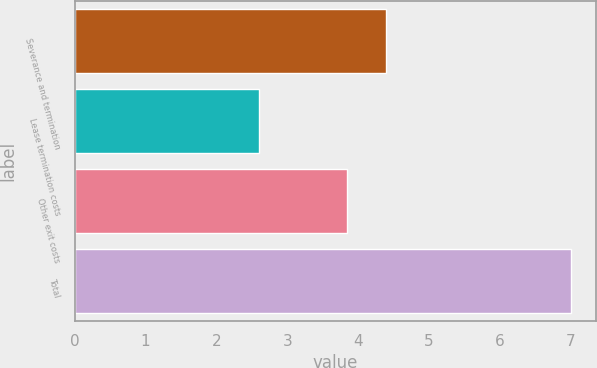Convert chart to OTSL. <chart><loc_0><loc_0><loc_500><loc_500><bar_chart><fcel>Severance and termination<fcel>Lease termination costs<fcel>Other exit costs<fcel>Total<nl><fcel>4.4<fcel>2.6<fcel>3.85<fcel>7<nl></chart> 